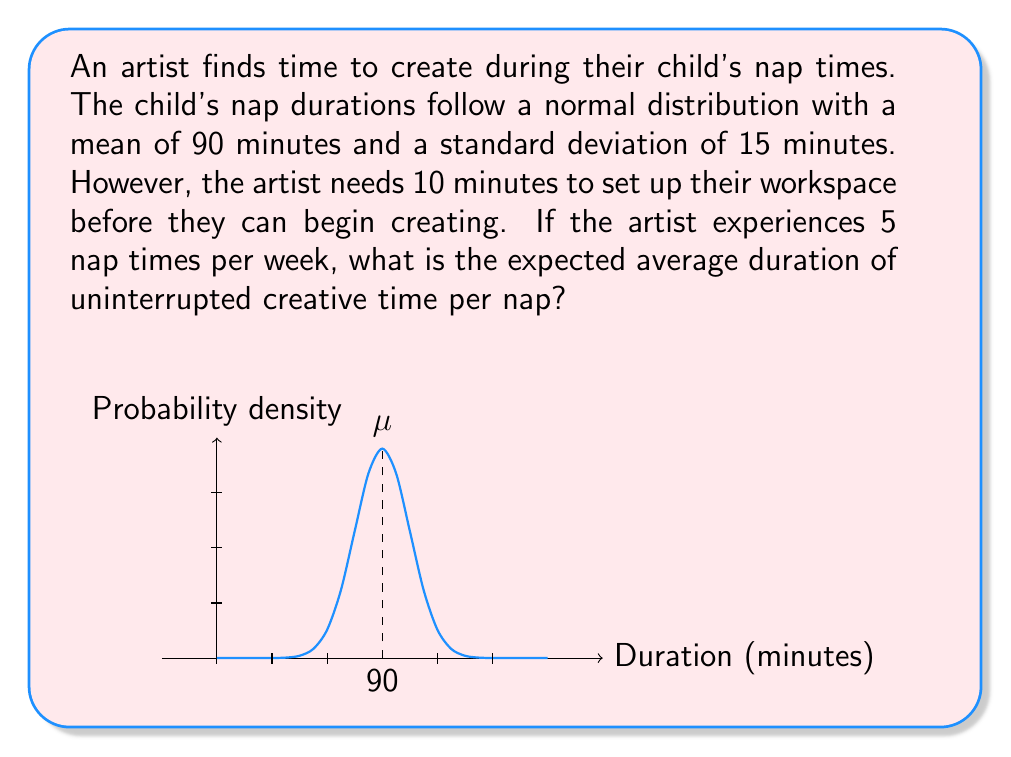Provide a solution to this math problem. Let's approach this step-by-step:

1) The nap durations follow a normal distribution with:
   $\mu = 90$ minutes
   $\sigma = 15$ minutes

2) The artist needs 10 minutes to set up, so the actual creative time is the nap duration minus 10 minutes.

3) The expected value of the creative time can be calculated as:
   $E[\text{Creative Time}] = E[\text{Nap Duration}] - 10$

4) Since the nap duration follows a normal distribution, its expected value is equal to its mean:
   $E[\text{Nap Duration}] = \mu = 90$ minutes

5) Therefore, the expected creative time is:
   $E[\text{Creative Time}] = 90 - 10 = 80$ minutes

6) This is the average duration of uninterrupted creative time per nap.

Note: The standard deviation doesn't affect the expected value in this case, but it would be relevant if we were calculating probabilities or ranges of creative time.
Answer: 80 minutes 